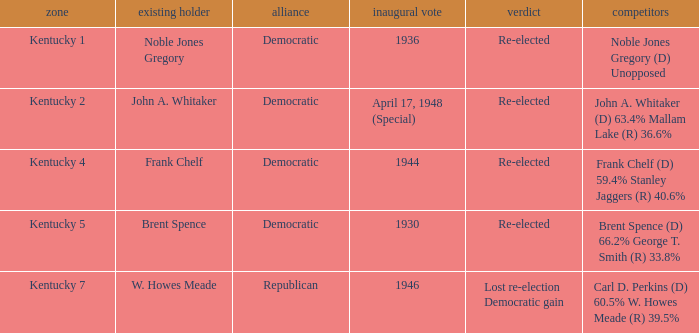How many times was incumbent Noble Jones Gregory first elected? 1.0. 